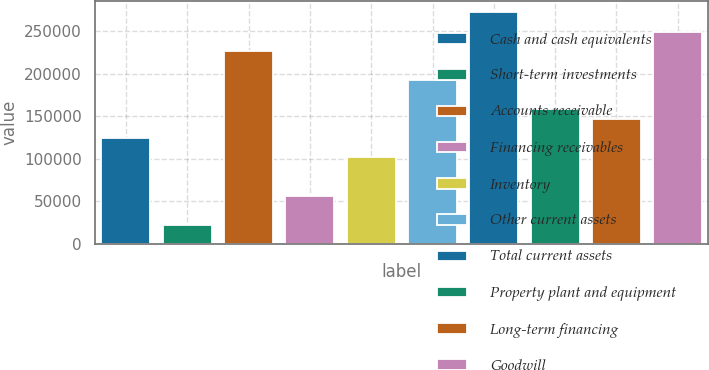<chart> <loc_0><loc_0><loc_500><loc_500><bar_chart><fcel>Cash and cash equivalents<fcel>Short-term investments<fcel>Accounts receivable<fcel>Financing receivables<fcel>Inventory<fcel>Other current assets<fcel>Total current assets<fcel>Property plant and equipment<fcel>Long-term financing<fcel>Goodwill<nl><fcel>124662<fcel>22685.4<fcel>226638<fcel>56677.5<fcel>102000<fcel>192646<fcel>271961<fcel>158654<fcel>147323<fcel>249299<nl></chart> 